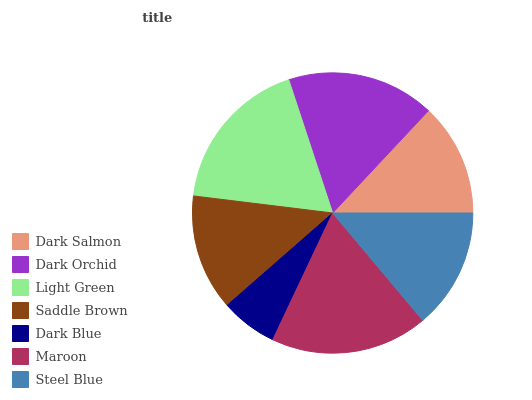Is Dark Blue the minimum?
Answer yes or no. Yes. Is Maroon the maximum?
Answer yes or no. Yes. Is Dark Orchid the minimum?
Answer yes or no. No. Is Dark Orchid the maximum?
Answer yes or no. No. Is Dark Orchid greater than Dark Salmon?
Answer yes or no. Yes. Is Dark Salmon less than Dark Orchid?
Answer yes or no. Yes. Is Dark Salmon greater than Dark Orchid?
Answer yes or no. No. Is Dark Orchid less than Dark Salmon?
Answer yes or no. No. Is Steel Blue the high median?
Answer yes or no. Yes. Is Steel Blue the low median?
Answer yes or no. Yes. Is Dark Blue the high median?
Answer yes or no. No. Is Saddle Brown the low median?
Answer yes or no. No. 